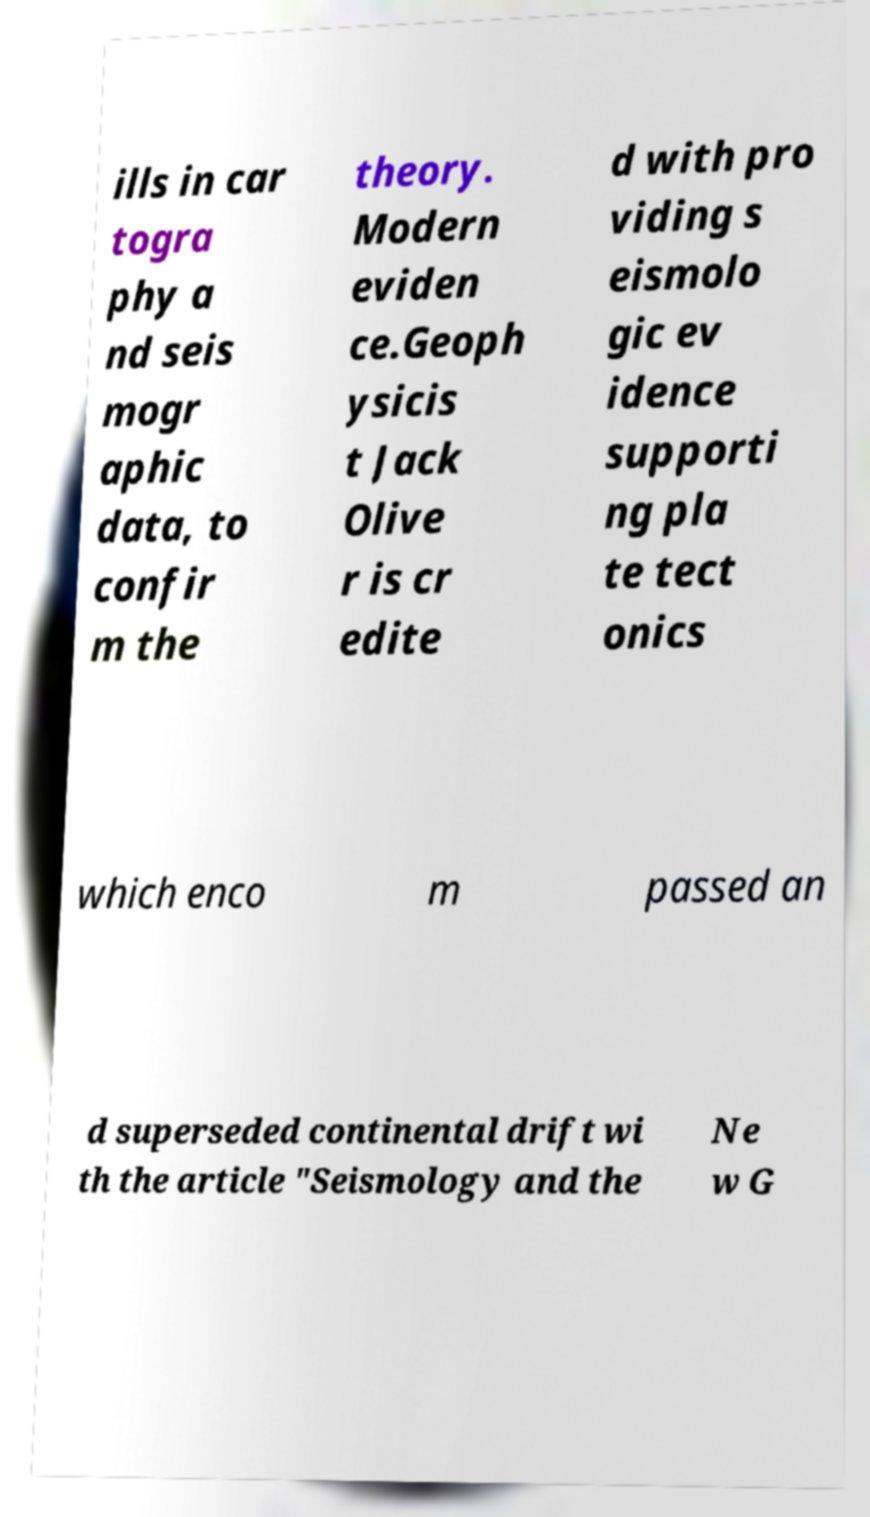Could you extract and type out the text from this image? ills in car togra phy a nd seis mogr aphic data, to confir m the theory. Modern eviden ce.Geoph ysicis t Jack Olive r is cr edite d with pro viding s eismolo gic ev idence supporti ng pla te tect onics which enco m passed an d superseded continental drift wi th the article "Seismology and the Ne w G 